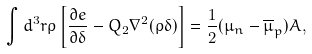<formula> <loc_0><loc_0><loc_500><loc_500>\int d ^ { 3 } r \rho \left [ \frac { \partial e } { \partial \delta } - Q _ { 2 } \nabla ^ { 2 } ( \rho \delta ) \right ] = \frac { 1 } { 2 } ( \mu _ { n } - \overline { \mu } _ { p } ) A ,</formula> 